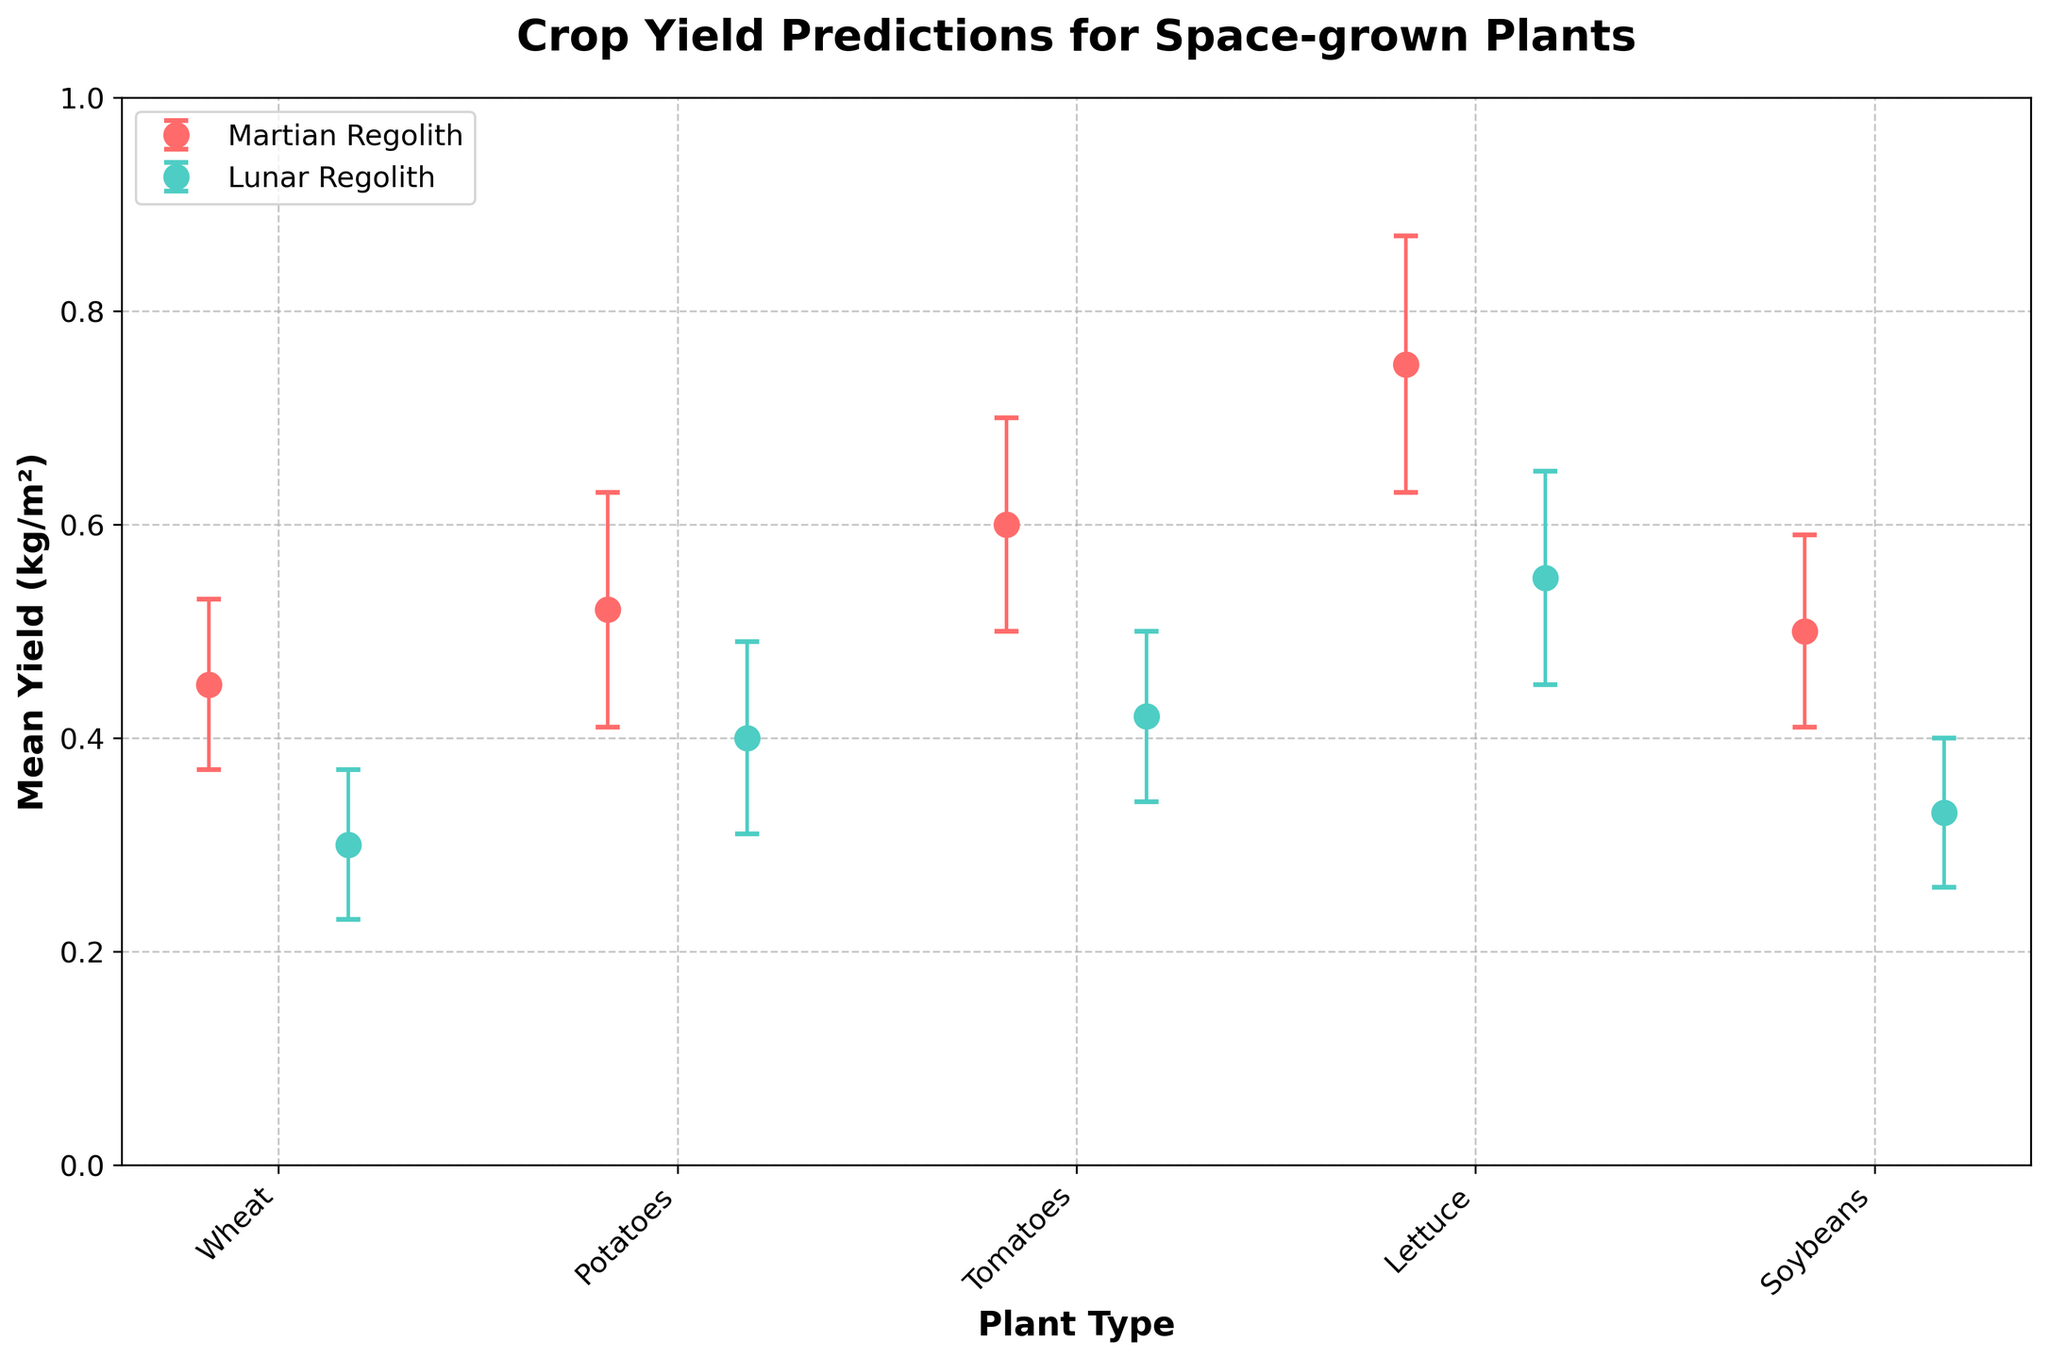What's the title of the figure? The title of the figure is displayed at the top and reads "Crop Yield Predictions for Space-grown Plants".
Answer: Crop Yield Predictions for Space-grown Plants How many types of plants are included in this figure? Count the unique plants listed on the x-axis labels: Wheat, Potatoes, Tomatoes, Lettuce, and Soybeans.
Answer: 5 Which plant type has the highest mean yield in Martian Regolith? Look at the dots representing Martian Regolith (red) and find the highest point on the y-axis. Lettuce has the highest mean yield in Martian Regolith.
Answer: Lettuce What is the approximate difference in mean yield for Tomatoes between Martian and Lunar Regolith? Identify the mean yield for Tomatoes in both soil conditions, then subtract the mean yield in Lunar Regolith from the mean yield in Martian Regolith (0.60 - 0.42).
Answer: 0.18 How does the mean yield of Wheat in Lunar Regolith compare to that in Martian Regolith? Compare the mean yield values of Wheat in both conditions; Martian Regolith is 0.45 and Lunar Regolith is 0.30. Martian Regolith has a higher mean yield for Wheat.
Answer: Higher in Martian Regolith What is the range of the mean yield for Lettuce in Martian Regolith with error bars considered? Add and subtract the standard deviation from the mean yield of Lettuce in Martian Regolith (0.75 ± 0.12), giving a range from (0.75 - 0.12) to (0.75 + 0.12).
Answer: 0.63 to 0.87 Which type of plant has the smallest standard deviation in yield for Martian Regolith? Examine the error bars (length) for each plant in Martian Regolith and find the smallest. Wheat has the smallest standard deviation (0.08).
Answer: Wheat What is the mean yield of Potatoes in Lunar Regolith? Find the data point for Potatoes in Lunar Regolith and read the mean yield value.
Answer: 0.40 Which soil condition generally results in a higher yield according to the figure? Compare the overall heights of the data points (red for Martian Regolith and teal for Lunar Regolith). Martian Regolith generally shows higher yields.
Answer: Martian Regolith Are there any plant types where the mean yield in Lunar Regolith is higher than in Martian Regolith? Compare each plant's mean yield in both conditions. None of the plants have a higher mean yield in Lunar Regolith.
Answer: No 